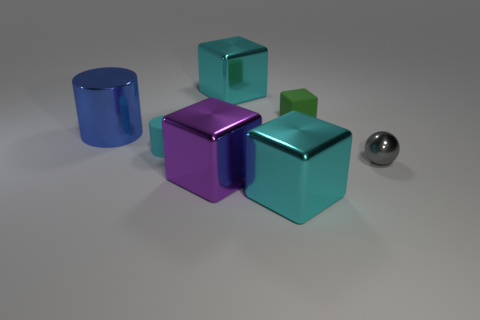How many gray things are small metallic balls or blocks?
Offer a very short reply. 1. What number of rubber objects are the same size as the cyan rubber cylinder?
Ensure brevity in your answer.  1. Do the large cyan thing in front of the gray object and the blue thing have the same material?
Provide a short and direct response. Yes. Are there any big blue cylinders right of the big thing that is on the left side of the purple thing?
Offer a very short reply. No. What is the material of the other thing that is the same shape as the blue metal object?
Your answer should be very brief. Rubber. Is the number of big purple shiny cubes in front of the small green matte thing greater than the number of large cyan shiny cubes in front of the shiny cylinder?
Offer a very short reply. No. The other tiny thing that is made of the same material as the tiny cyan object is what shape?
Give a very brief answer. Cube. Is the number of tiny rubber things in front of the tiny rubber block greater than the number of metal cubes?
Ensure brevity in your answer.  No. What number of tiny rubber cylinders are the same color as the metal sphere?
Keep it short and to the point. 0. What number of other objects are the same color as the tiny metal ball?
Your answer should be compact. 0. 